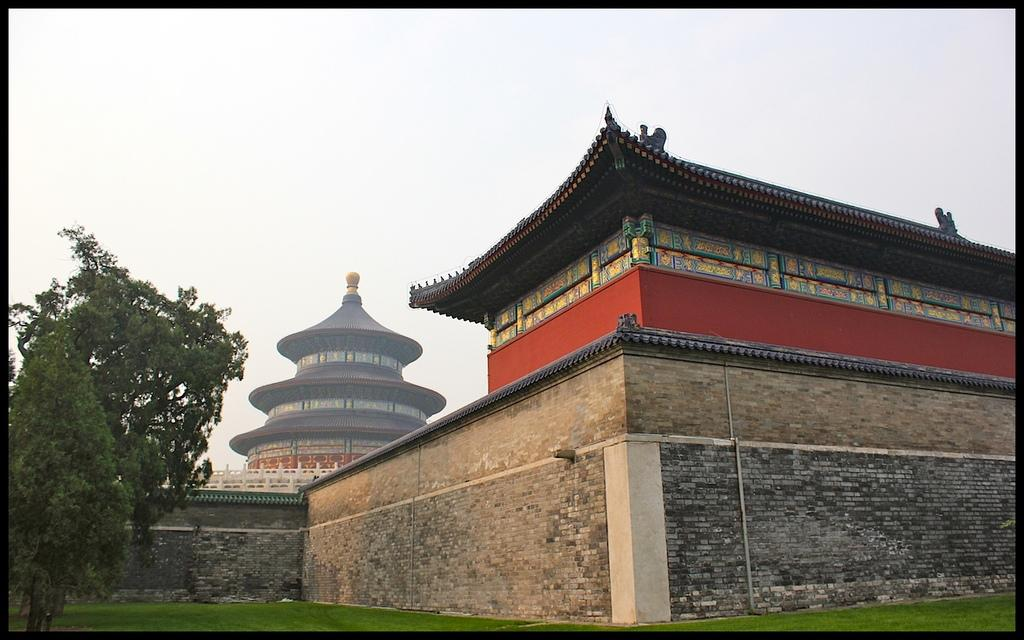What is the main element in the center of the image? The center of the image contains the sky. What type of vegetation can be seen in the image? Trees are present in the image. Are there any structures visible in the image? Yes, there is at least one building in the image. What type of ground surface is visible in the image? Grass is visible in the image. What is the color of the border surrounding the image? The image has a black colored border. What type of lumber is being used to construct the building in the image? There is no information about the type of lumber used in the construction of the building in the image. What vegetables can be seen growing in the image? There are no vegetables visible in the image. 